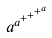Convert formula to latex. <formula><loc_0><loc_0><loc_500><loc_500>a ^ { a ^ { + ^ { + ^ { + ^ { a } } } } }</formula> 